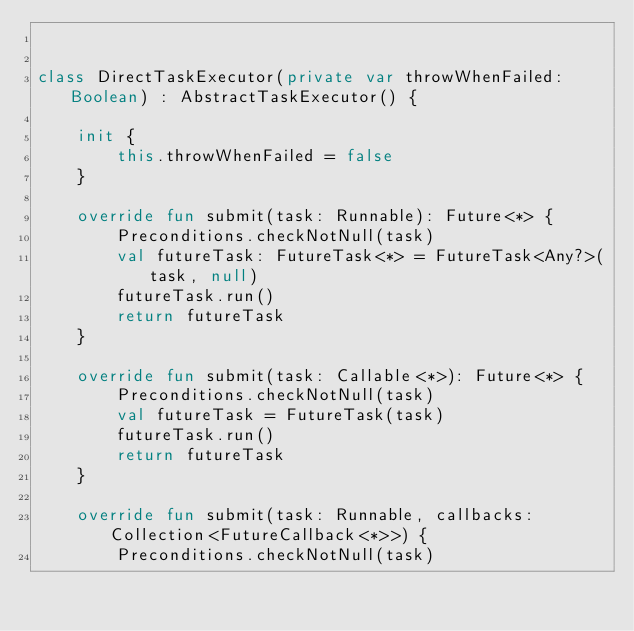<code> <loc_0><loc_0><loc_500><loc_500><_Kotlin_>

class DirectTaskExecutor(private var throwWhenFailed: Boolean) : AbstractTaskExecutor() {

    init {
        this.throwWhenFailed = false
    }

    override fun submit(task: Runnable): Future<*> {
        Preconditions.checkNotNull(task)
        val futureTask: FutureTask<*> = FutureTask<Any?>(task, null)
        futureTask.run()
        return futureTask
    }

    override fun submit(task: Callable<*>): Future<*> {
        Preconditions.checkNotNull(task)
        val futureTask = FutureTask(task)
        futureTask.run()
        return futureTask
    }

    override fun submit(task: Runnable, callbacks: Collection<FutureCallback<*>>) {
        Preconditions.checkNotNull(task)</code> 